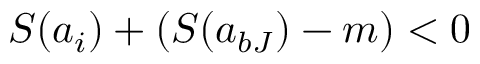<formula> <loc_0><loc_0><loc_500><loc_500>S ( a _ { i } ) + ( S ( a _ { b J } ) - m ) < 0</formula> 